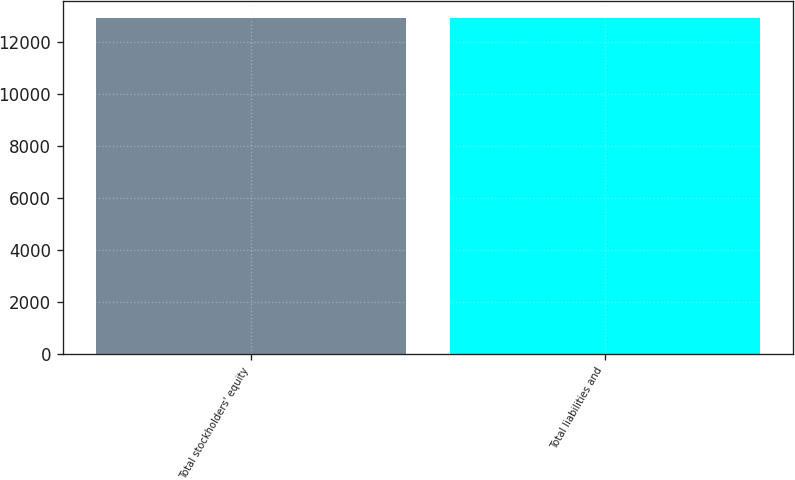<chart> <loc_0><loc_0><loc_500><loc_500><bar_chart><fcel>Total stockholders' equity<fcel>Total liabilities and<nl><fcel>12951.6<fcel>12951.7<nl></chart> 